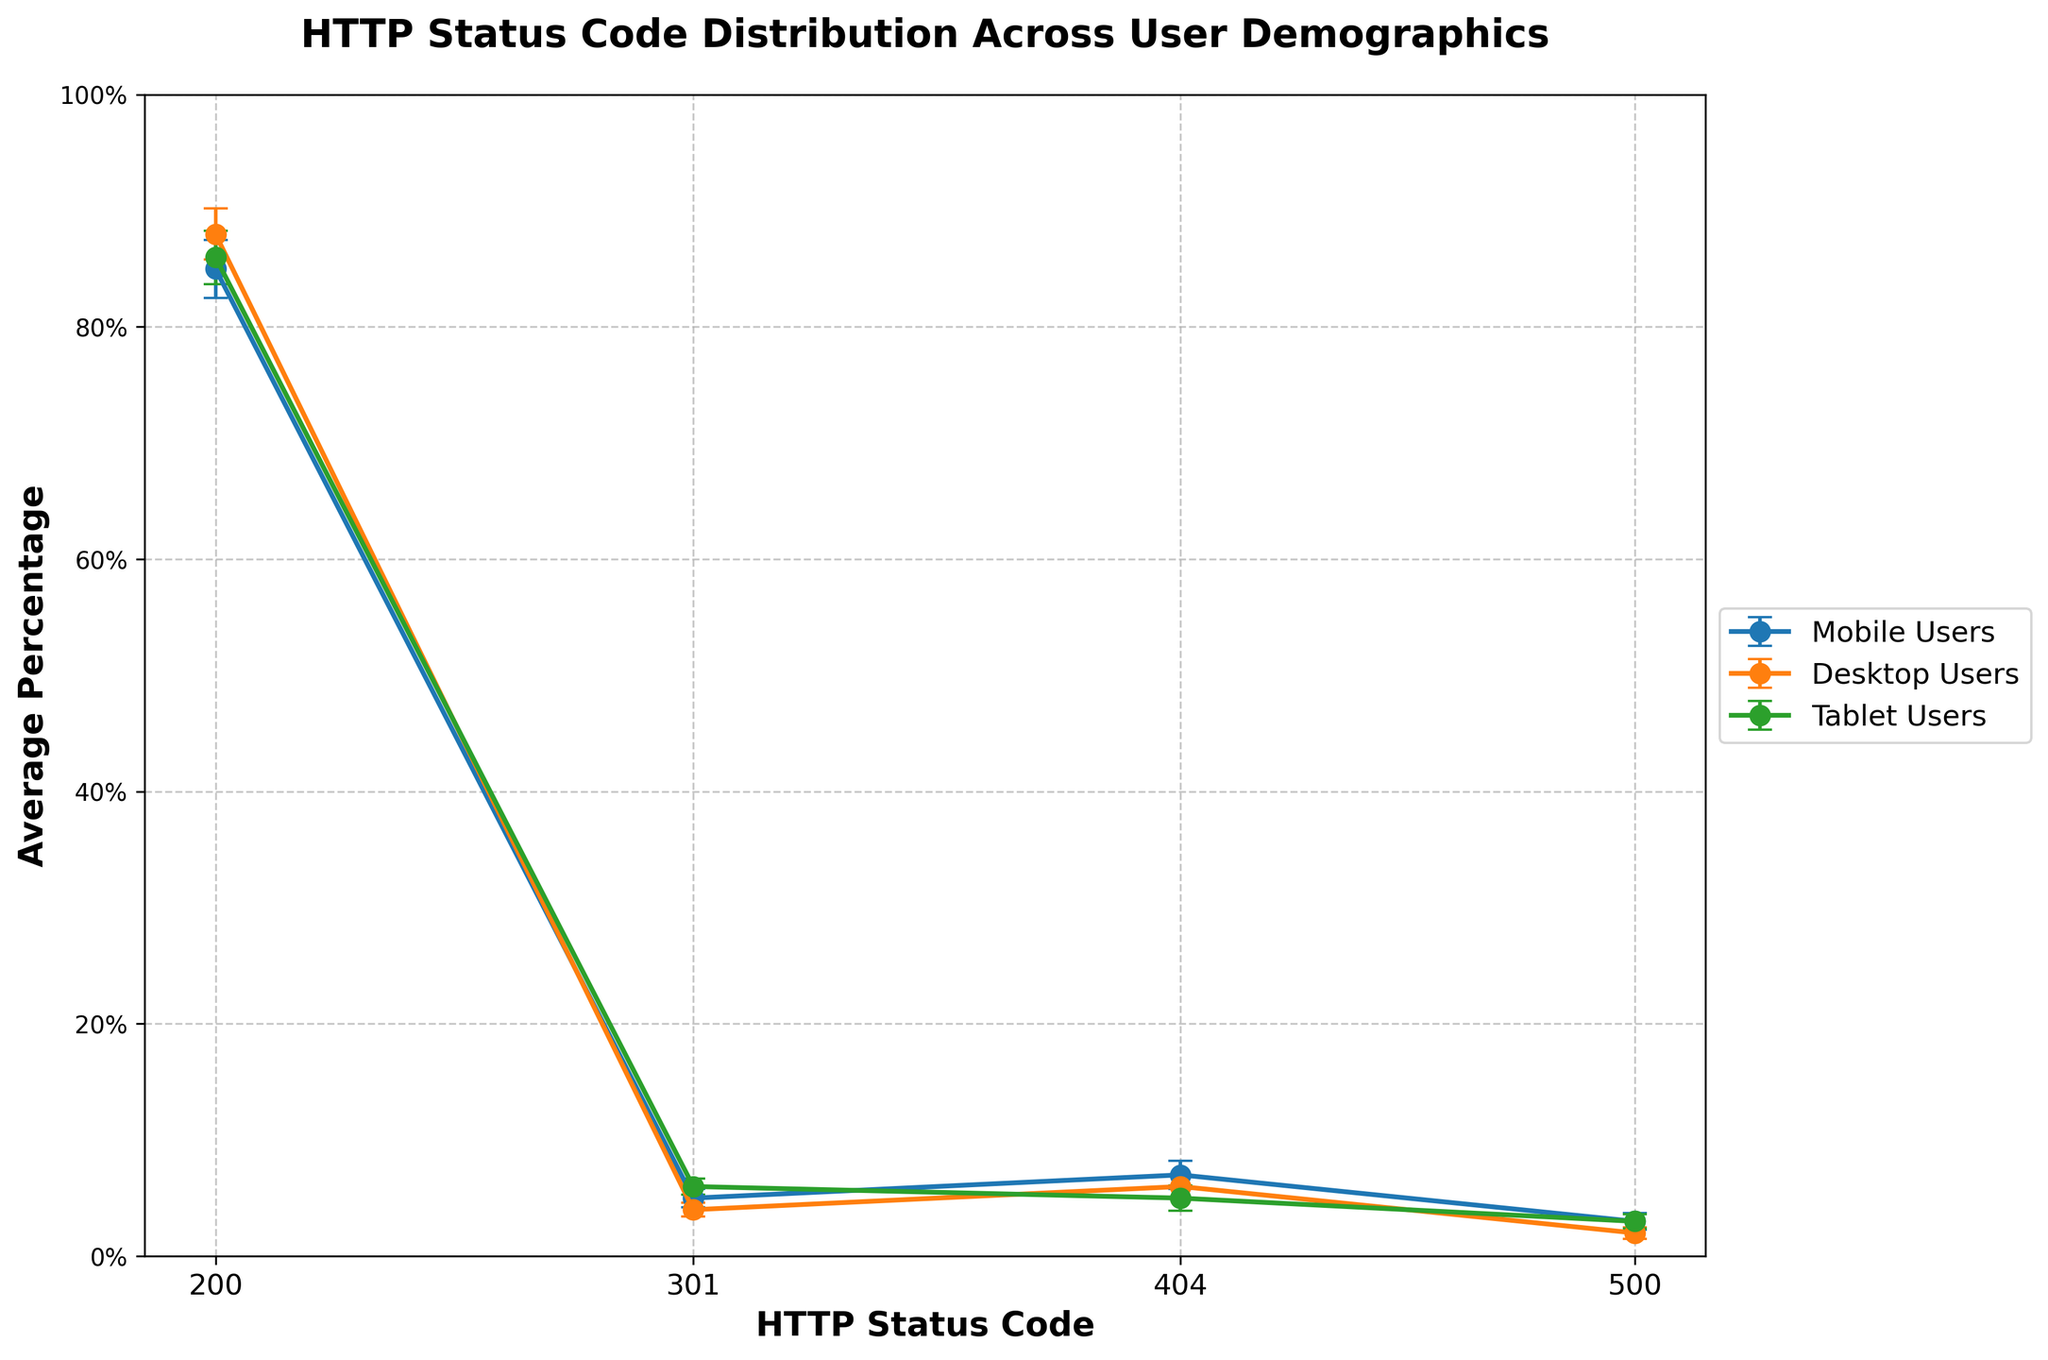What is the title of the plot? The title of the plot is displayed at the top in bold and larger font than other text elements. The title reads "HTTP Status Code Distribution Across User Demographics".
Answer: HTTP Status Code Distribution Across User Demographics Which user demographic has the highest average percentage for HTTP 200 status code? To find this, look at the highest point on the y-axis for HTTP status code 200 among the different demographics. The highest average percentage for HTTP 200 is for Desktop Users, which is 88%.
Answer: Desktop Users What is the average percentage of HTTP 404 status code for Mobile Users? Locate the data point for Mobile Users at the HTTP 404 status code. The y-axis value corresponding to this point is 7%.
Answer: 7% How does the error margin for HTTP 500 status code compare between Desktop Users and Tablet Users? Compare the length of the error bars for HTTP 500 between Desktop Users and Tablet Users. Desktop Users have an error margin of 0.5, while Tablet Users have an error margin of 0.6.
Answer: Tablet Users have a slightly larger error margin Which demographic has the smallest error margin for HTTP 301 status code? Compare the error margins for HTTP 301 across all demographics by looking at the size of the error bars. Desktop Users have the smallest error margin of 0.6.
Answer: Desktop Users Estimate the difference in average percentage for HTTP 301 between Mobile Users and Tablet Users. Find the y-values for HTTP 301 of Mobile Users (5%) and Tablet Users (6%). The difference is calculated as 6% - 5% = 1%.
Answer: 1% What is the range of the HTTP 200 average percentage for Mobile Users considering the error margin? To find the range, add and subtract the error margin (2.5%) from the average value (85%) for Mobile Users. The range is [82.5%, 87.5%].
Answer: [82.5%, 87.5%] Which HTTP status code has the largest variation, and which demographic contributes to that? Look for the longest error bar across all status codes and demographics. HTTP 200 across all demographics has noticeable variations, but the largest error margin for HTTP 404 is in Mobile Users with 1.2%, influencing this variation significantly.
Answer: HTTP 404, Mobile Users What is the overall trend in the average percentage of HTTP 200 status codes across the different demographics? Assess the data points for HTTP 200 in each demographic. The average percentages are 85% for Mobile Users, 88% for Desktop Users, and 86% for Tablet Users. The overall trend shows that the HTTP 200 status code is consistently high across all demographics.
Answer: High and consistent across all demographics 